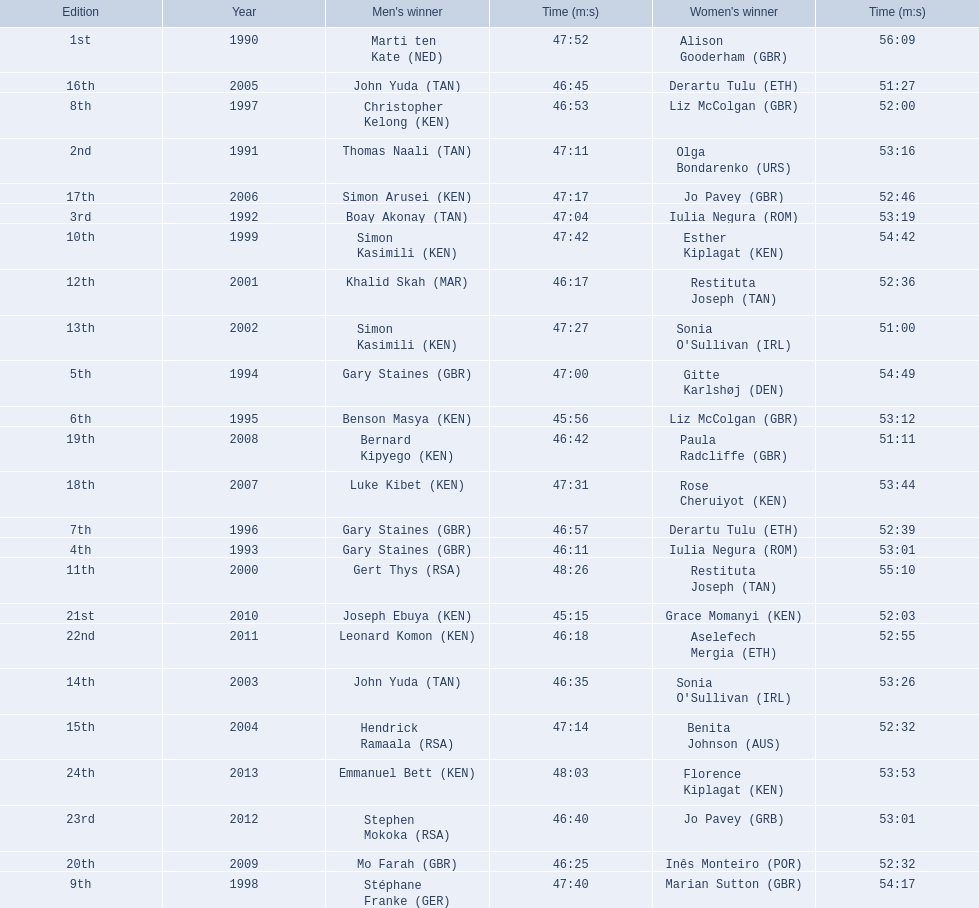What years were the races held? 1990, 1991, 1992, 1993, 1994, 1995, 1996, 1997, 1998, 1999, 2000, 2001, 2002, 2003, 2004, 2005, 2006, 2007, 2008, 2009, 2010, 2011, 2012, 2013. Help me parse the entirety of this table. {'header': ['Edition', 'Year', "Men's winner", 'Time (m:s)', "Women's winner", 'Time (m:s)'], 'rows': [['1st', '1990', 'Marti ten Kate\xa0(NED)', '47:52', 'Alison Gooderham\xa0(GBR)', '56:09'], ['16th', '2005', 'John Yuda\xa0(TAN)', '46:45', 'Derartu Tulu\xa0(ETH)', '51:27'], ['8th', '1997', 'Christopher Kelong\xa0(KEN)', '46:53', 'Liz McColgan\xa0(GBR)', '52:00'], ['2nd', '1991', 'Thomas Naali\xa0(TAN)', '47:11', 'Olga Bondarenko\xa0(URS)', '53:16'], ['17th', '2006', 'Simon Arusei\xa0(KEN)', '47:17', 'Jo Pavey\xa0(GBR)', '52:46'], ['3rd', '1992', 'Boay Akonay\xa0(TAN)', '47:04', 'Iulia Negura\xa0(ROM)', '53:19'], ['10th', '1999', 'Simon Kasimili\xa0(KEN)', '47:42', 'Esther Kiplagat\xa0(KEN)', '54:42'], ['12th', '2001', 'Khalid Skah\xa0(MAR)', '46:17', 'Restituta Joseph\xa0(TAN)', '52:36'], ['13th', '2002', 'Simon Kasimili\xa0(KEN)', '47:27', "Sonia O'Sullivan\xa0(IRL)", '51:00'], ['5th', '1994', 'Gary Staines\xa0(GBR)', '47:00', 'Gitte Karlshøj\xa0(DEN)', '54:49'], ['6th', '1995', 'Benson Masya\xa0(KEN)', '45:56', 'Liz McColgan\xa0(GBR)', '53:12'], ['19th', '2008', 'Bernard Kipyego\xa0(KEN)', '46:42', 'Paula Radcliffe\xa0(GBR)', '51:11'], ['18th', '2007', 'Luke Kibet\xa0(KEN)', '47:31', 'Rose Cheruiyot\xa0(KEN)', '53:44'], ['7th', '1996', 'Gary Staines\xa0(GBR)', '46:57', 'Derartu Tulu\xa0(ETH)', '52:39'], ['4th', '1993', 'Gary Staines\xa0(GBR)', '46:11', 'Iulia Negura\xa0(ROM)', '53:01'], ['11th', '2000', 'Gert Thys\xa0(RSA)', '48:26', 'Restituta Joseph\xa0(TAN)', '55:10'], ['21st', '2010', 'Joseph Ebuya\xa0(KEN)', '45:15', 'Grace Momanyi\xa0(KEN)', '52:03'], ['22nd', '2011', 'Leonard Komon\xa0(KEN)', '46:18', 'Aselefech Mergia\xa0(ETH)', '52:55'], ['14th', '2003', 'John Yuda\xa0(TAN)', '46:35', "Sonia O'Sullivan\xa0(IRL)", '53:26'], ['15th', '2004', 'Hendrick Ramaala\xa0(RSA)', '47:14', 'Benita Johnson\xa0(AUS)', '52:32'], ['24th', '2013', 'Emmanuel Bett\xa0(KEN)', '48:03', 'Florence Kiplagat\xa0(KEN)', '53:53'], ['23rd', '2012', 'Stephen Mokoka\xa0(RSA)', '46:40', 'Jo Pavey\xa0(GRB)', '53:01'], ['20th', '2009', 'Mo Farah\xa0(GBR)', '46:25', 'Inês Monteiro\xa0(POR)', '52:32'], ['9th', '1998', 'Stéphane Franke\xa0(GER)', '47:40', 'Marian Sutton\xa0(GBR)', '54:17']]} Who was the woman's winner of the 2003 race? Sonia O'Sullivan (IRL). What was her time? 53:26. 